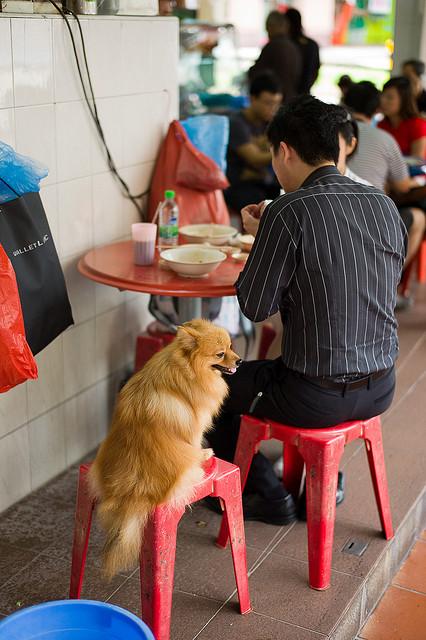Is the man in a fast food restaurant?
Give a very brief answer. Yes. What is the dog sitting on?
Quick response, please. Stool. What is the dogs comfort level?
Be succinct. Medium. 